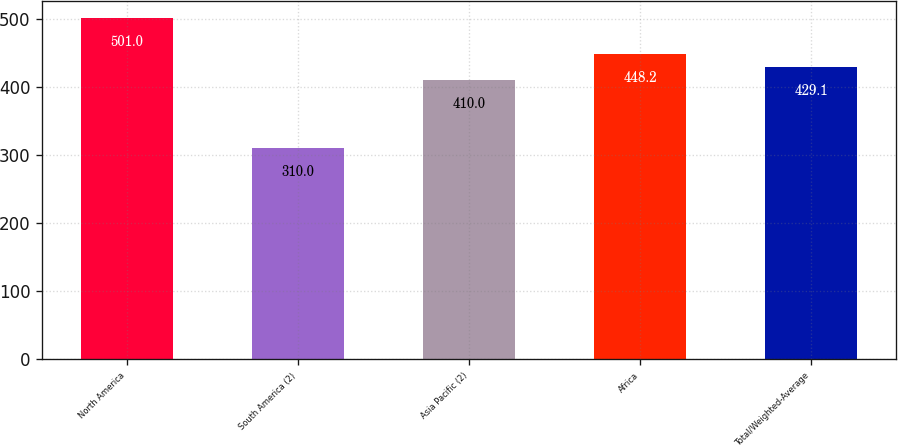<chart> <loc_0><loc_0><loc_500><loc_500><bar_chart><fcel>North America<fcel>South America (2)<fcel>Asia Pacific (2)<fcel>Africa<fcel>Total/Weighted-Average<nl><fcel>501<fcel>310<fcel>410<fcel>448.2<fcel>429.1<nl></chart> 